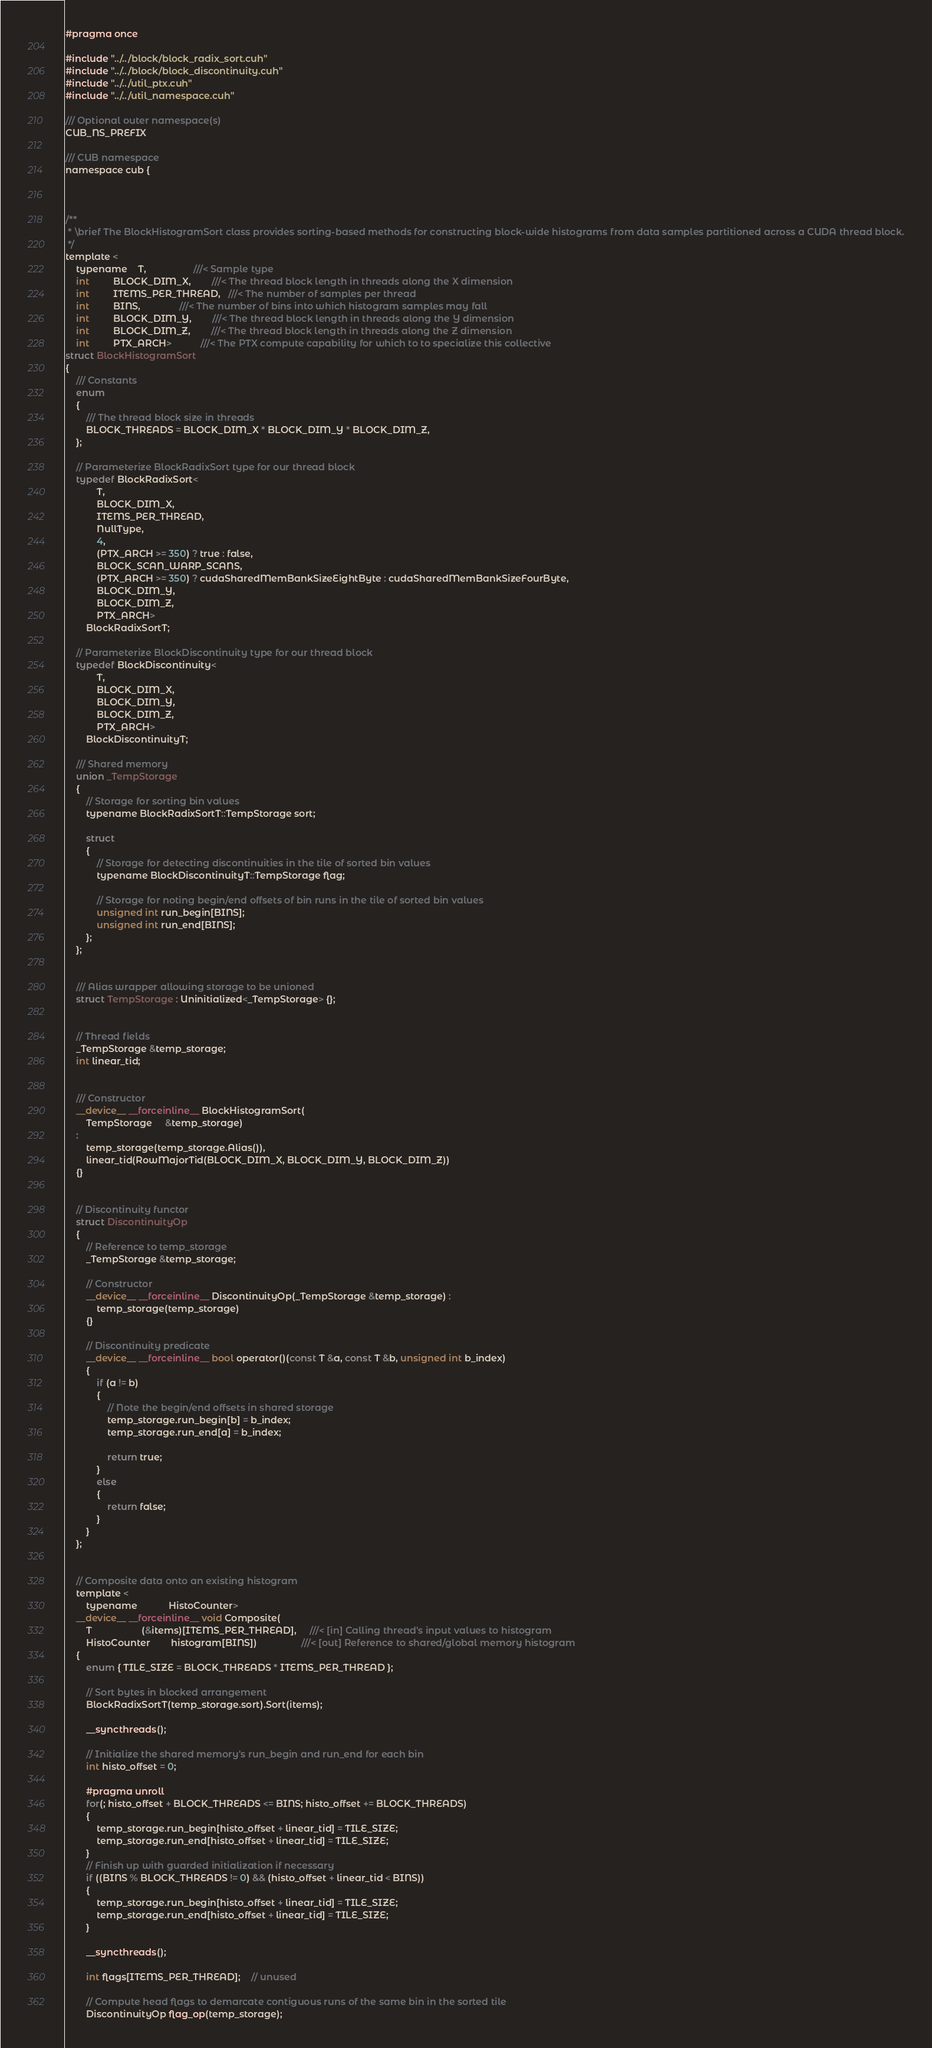<code> <loc_0><loc_0><loc_500><loc_500><_Cuda_>#pragma once

#include "../../block/block_radix_sort.cuh"
#include "../../block/block_discontinuity.cuh"
#include "../../util_ptx.cuh"
#include "../../util_namespace.cuh"

/// Optional outer namespace(s)
CUB_NS_PREFIX

/// CUB namespace
namespace cub {



/**
 * \brief The BlockHistogramSort class provides sorting-based methods for constructing block-wide histograms from data samples partitioned across a CUDA thread block.
 */
template <
    typename    T,                  ///< Sample type
    int         BLOCK_DIM_X,        ///< The thread block length in threads along the X dimension
    int         ITEMS_PER_THREAD,   ///< The number of samples per thread
    int         BINS,               ///< The number of bins into which histogram samples may fall
    int         BLOCK_DIM_Y,        ///< The thread block length in threads along the Y dimension
    int         BLOCK_DIM_Z,        ///< The thread block length in threads along the Z dimension
    int         PTX_ARCH>           ///< The PTX compute capability for which to to specialize this collective
struct BlockHistogramSort
{
    /// Constants
    enum
    {
        /// The thread block size in threads
        BLOCK_THREADS = BLOCK_DIM_X * BLOCK_DIM_Y * BLOCK_DIM_Z,
    };

    // Parameterize BlockRadixSort type for our thread block
    typedef BlockRadixSort<
            T,
            BLOCK_DIM_X,
            ITEMS_PER_THREAD,
            NullType,
            4,
            (PTX_ARCH >= 350) ? true : false,
            BLOCK_SCAN_WARP_SCANS,
            (PTX_ARCH >= 350) ? cudaSharedMemBankSizeEightByte : cudaSharedMemBankSizeFourByte,
            BLOCK_DIM_Y,
            BLOCK_DIM_Z,
            PTX_ARCH>
        BlockRadixSortT;

    // Parameterize BlockDiscontinuity type for our thread block
    typedef BlockDiscontinuity<
            T,
            BLOCK_DIM_X,
            BLOCK_DIM_Y,
            BLOCK_DIM_Z,
            PTX_ARCH>
        BlockDiscontinuityT;

    /// Shared memory
    union _TempStorage
    {
        // Storage for sorting bin values
        typename BlockRadixSortT::TempStorage sort;

        struct
        {
            // Storage for detecting discontinuities in the tile of sorted bin values
            typename BlockDiscontinuityT::TempStorage flag;

            // Storage for noting begin/end offsets of bin runs in the tile of sorted bin values
            unsigned int run_begin[BINS];
            unsigned int run_end[BINS];
        };
    };


    /// Alias wrapper allowing storage to be unioned
    struct TempStorage : Uninitialized<_TempStorage> {};


    // Thread fields
    _TempStorage &temp_storage;
    int linear_tid;


    /// Constructor
    __device__ __forceinline__ BlockHistogramSort(
        TempStorage     &temp_storage)
    :
        temp_storage(temp_storage.Alias()),
        linear_tid(RowMajorTid(BLOCK_DIM_X, BLOCK_DIM_Y, BLOCK_DIM_Z))
    {}


    // Discontinuity functor
    struct DiscontinuityOp
    {
        // Reference to temp_storage
        _TempStorage &temp_storage;

        // Constructor
        __device__ __forceinline__ DiscontinuityOp(_TempStorage &temp_storage) :
            temp_storage(temp_storage)
        {}

        // Discontinuity predicate
        __device__ __forceinline__ bool operator()(const T &a, const T &b, unsigned int b_index)
        {
            if (a != b)
            {
                // Note the begin/end offsets in shared storage
                temp_storage.run_begin[b] = b_index;
                temp_storage.run_end[a] = b_index;

                return true;
            }
            else
            {
                return false;
            }
        }
    };


    // Composite data onto an existing histogram
    template <
        typename            HistoCounter>
    __device__ __forceinline__ void Composite(
        T                   (&items)[ITEMS_PER_THREAD],     ///< [in] Calling thread's input values to histogram
        HistoCounter        histogram[BINS])                 ///< [out] Reference to shared/global memory histogram
    {
        enum { TILE_SIZE = BLOCK_THREADS * ITEMS_PER_THREAD };

        // Sort bytes in blocked arrangement
        BlockRadixSortT(temp_storage.sort).Sort(items);

        __syncthreads();

        // Initialize the shared memory's run_begin and run_end for each bin
        int histo_offset = 0;

        #pragma unroll
        for(; histo_offset + BLOCK_THREADS <= BINS; histo_offset += BLOCK_THREADS)
        {
            temp_storage.run_begin[histo_offset + linear_tid] = TILE_SIZE;
            temp_storage.run_end[histo_offset + linear_tid] = TILE_SIZE;
        }
        // Finish up with guarded initialization if necessary
        if ((BINS % BLOCK_THREADS != 0) && (histo_offset + linear_tid < BINS))
        {
            temp_storage.run_begin[histo_offset + linear_tid] = TILE_SIZE;
            temp_storage.run_end[histo_offset + linear_tid] = TILE_SIZE;
        }

        __syncthreads();

        int flags[ITEMS_PER_THREAD];    // unused

        // Compute head flags to demarcate contiguous runs of the same bin in the sorted tile
        DiscontinuityOp flag_op(temp_storage);</code> 